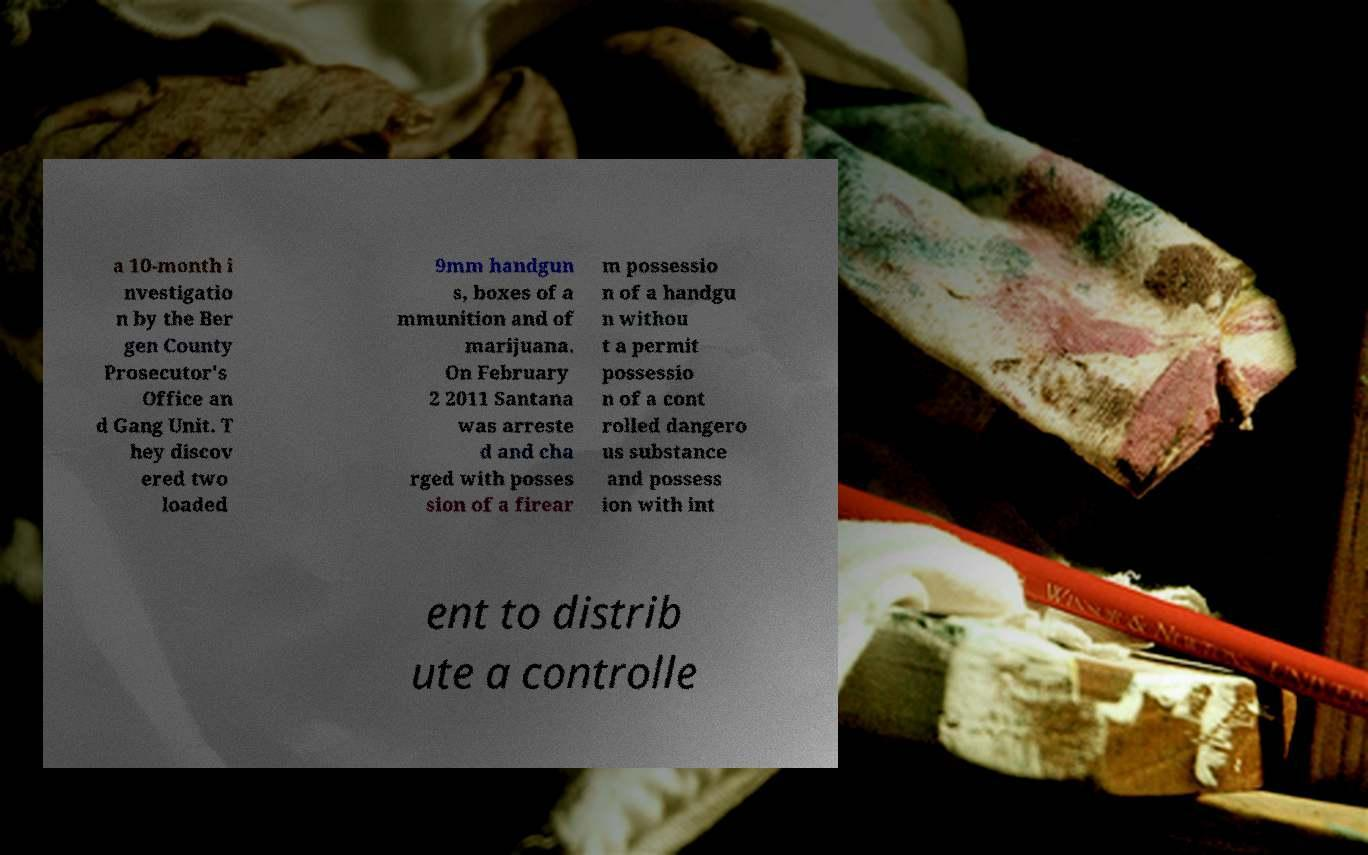What messages or text are displayed in this image? I need them in a readable, typed format. a 10-month i nvestigatio n by the Ber gen County Prosecutor's Office an d Gang Unit. T hey discov ered two loaded 9mm handgun s, boxes of a mmunition and of marijuana. On February 2 2011 Santana was arreste d and cha rged with posses sion of a firear m possessio n of a handgu n withou t a permit possessio n of a cont rolled dangero us substance and possess ion with int ent to distrib ute a controlle 